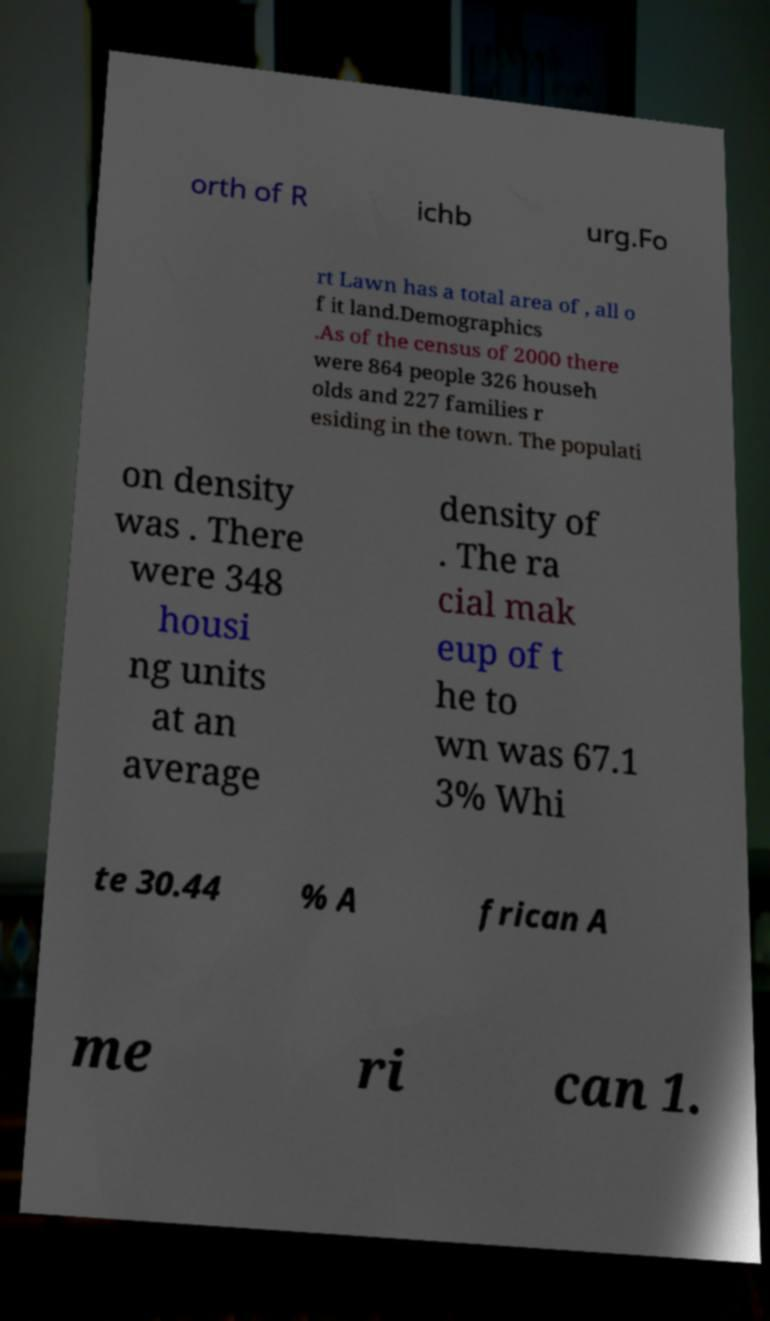There's text embedded in this image that I need extracted. Can you transcribe it verbatim? orth of R ichb urg.Fo rt Lawn has a total area of , all o f it land.Demographics .As of the census of 2000 there were 864 people 326 househ olds and 227 families r esiding in the town. The populati on density was . There were 348 housi ng units at an average density of . The ra cial mak eup of t he to wn was 67.1 3% Whi te 30.44 % A frican A me ri can 1. 